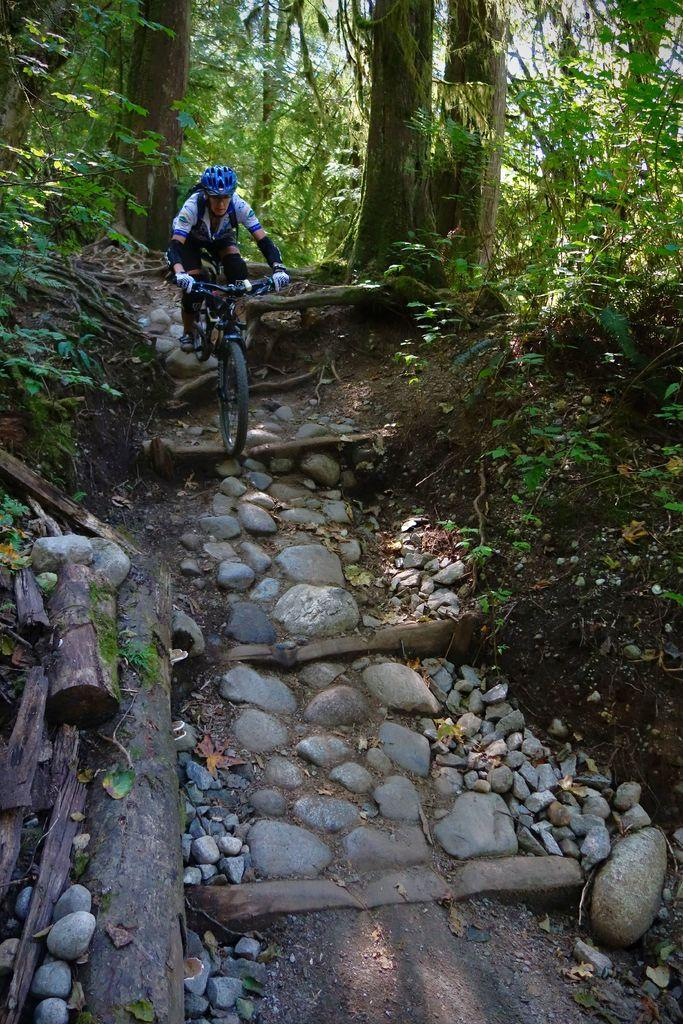What is the person in the image doing? A person is riding a bicycle in the image. What safety precaution is the person taking while riding the bicycle? The person is wearing a helmet. What is the person carrying while riding the bicycle? The person is carrying a bag. What type of natural elements can be seen in the image? There are rocks, branches, plants, and trees in the image. What color of paint is being used to decorate the marble in the image? There is no paint or marble present in the image; it features a person riding a bicycle with natural elements in the background. 